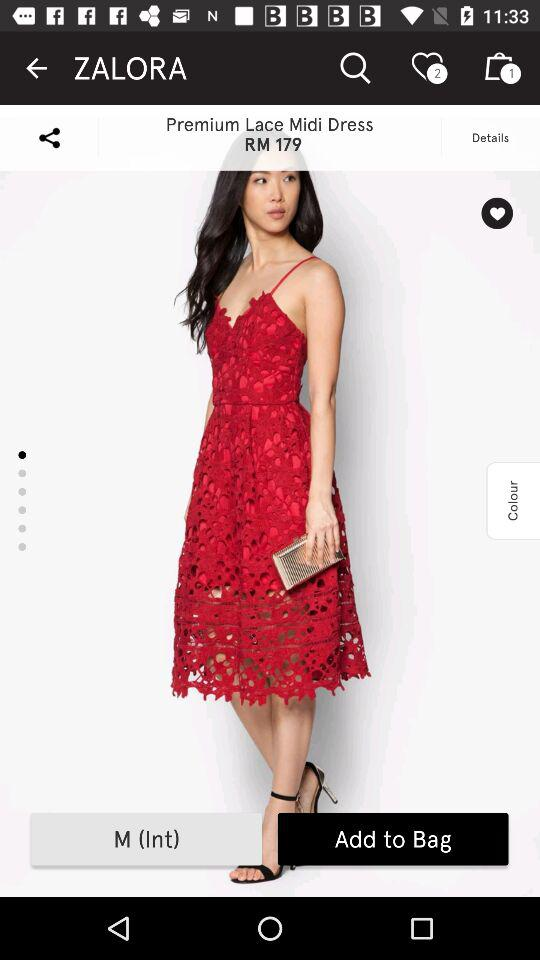How many sizes are available for this dress?
Answer the question using a single word or phrase. 1 